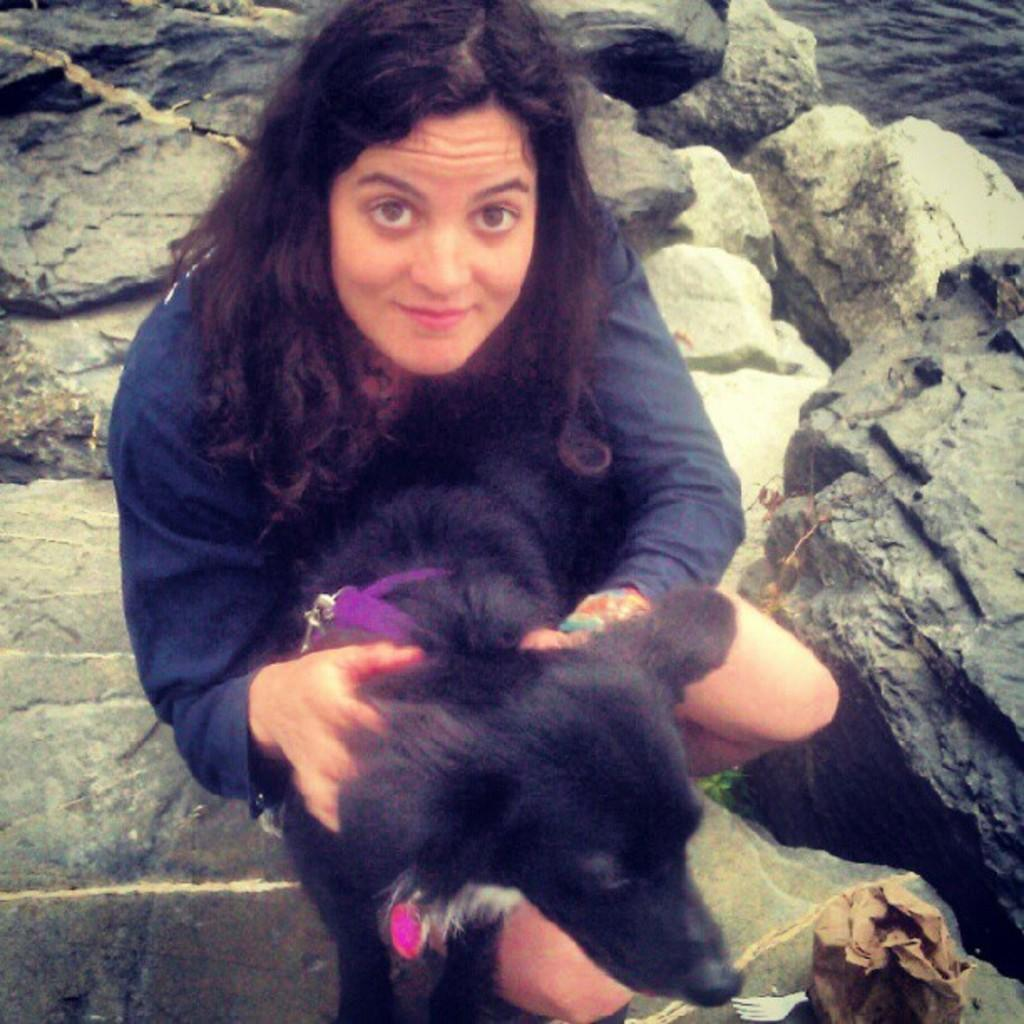What is the woman doing in the image? The woman is sitting in the image. What is the woman holding in the image? The woman is holding a dog in the image. What can be seen in the background of the image? There is a rock and water visible in the background of the image. What type of tooth is the woman using to teach the dog in the image? There is no tooth present in the image, and the woman is not teaching the dog. 